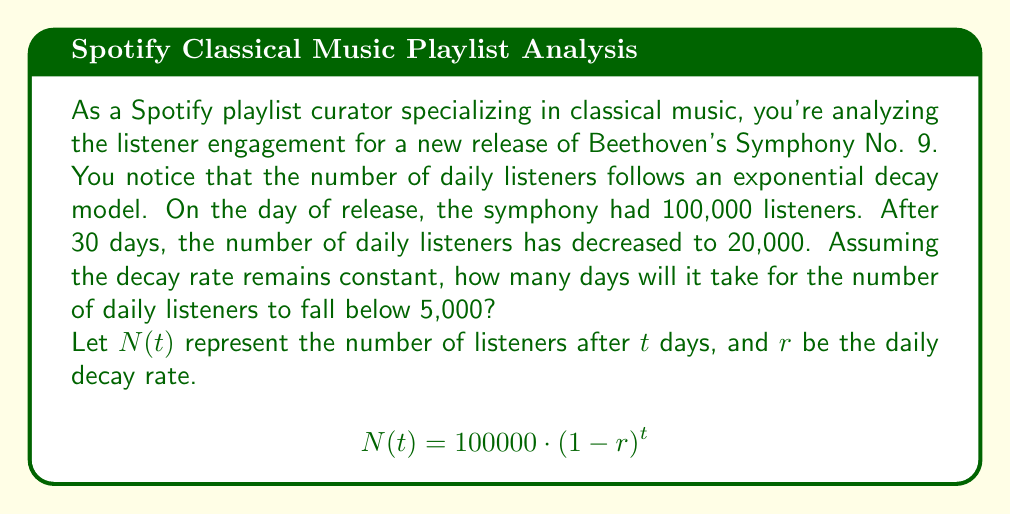Give your solution to this math problem. To solve this problem, we'll follow these steps:

1. Find the daily decay rate $(r)$ using the given information.
2. Set up an equation to solve for the number of days $(t)$ when listeners fall below 5,000.
3. Solve the equation for $t$.

Step 1: Finding the daily decay rate $(r)$

We know that after 30 days, there are 20,000 listeners. We can use this to set up an equation:

$$20000 = 100000 \cdot (1-r)^{30}$$

Dividing both sides by 100000:

$$0.2 = (1-r)^{30}$$

Taking the 30th root of both sides:

$$(0.2)^{\frac{1}{30}} = 1-r$$

$$1 - (0.2)^{\frac{1}{30}} = r$$

$$r \approx 0.0513$$ or about 5.13% daily decay rate

Step 2: Setting up the equation for 5,000 listeners

Now we want to find $t$ when $N(t) = 5000$:

$$5000 = 100000 \cdot (1-0.0513)^t$$

Step 3: Solving for $t$

Dividing both sides by 100000:

$$0.05 = (1-0.0513)^t$$

Taking the natural log of both sides:

$$\ln(0.05) = t \cdot \ln(1-0.0513)$$

Solving for $t$:

$$t = \frac{\ln(0.05)}{\ln(1-0.0513)} \approx 57.8$$

Since we can only have a whole number of days, we round up to the next integer.
Answer: It will take 58 days for the number of daily listeners to fall below 5,000. 